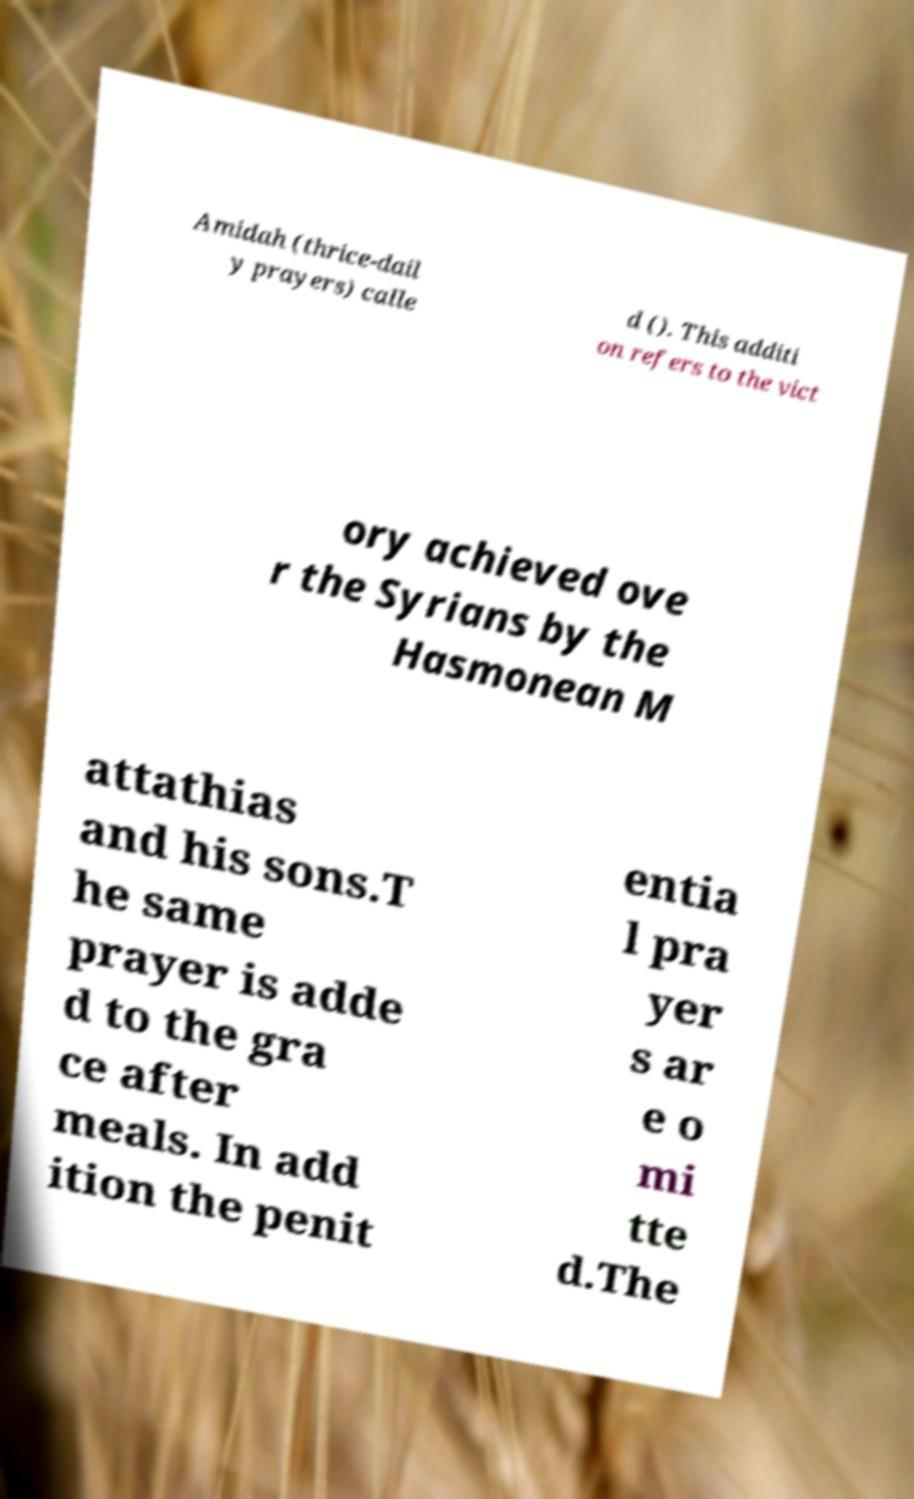For documentation purposes, I need the text within this image transcribed. Could you provide that? Amidah (thrice-dail y prayers) calle d (). This additi on refers to the vict ory achieved ove r the Syrians by the Hasmonean M attathias and his sons.T he same prayer is adde d to the gra ce after meals. In add ition the penit entia l pra yer s ar e o mi tte d.The 